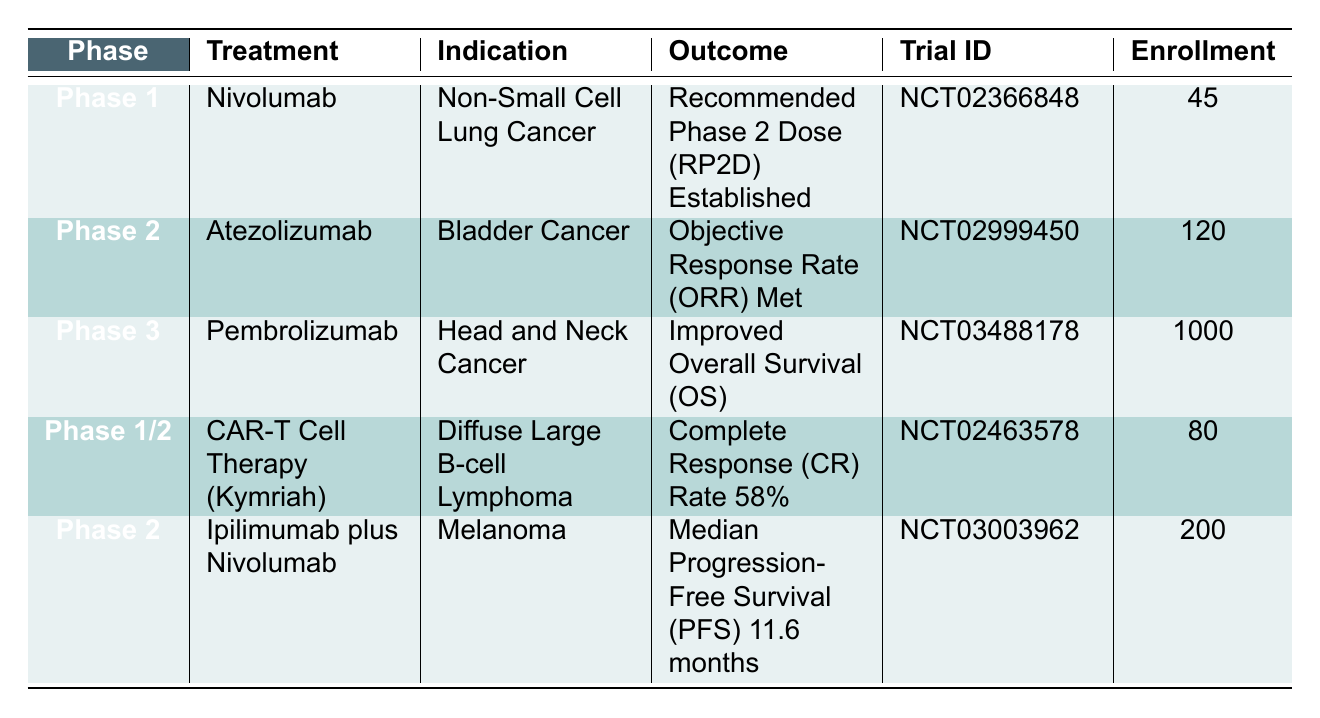What is the treatment used in the trial with ID NCT03003962? Referring to the table, the trial with ID NCT03003962 corresponds to the treatment "Ipilimumab plus Nivolumab."
Answer: Ipilimumab plus Nivolumab Which phase has the highest enrollment? By examining the enrollment column, Phase 3 with treatment Pembrolizumab has the highest number of enrollments at 1000.
Answer: Phase 3 Is the outcome of the CAR-T Cell Therapy trial a complete response rate? The table states that the outcome for the CAR-T Cell Therapy (Kymriah) trial is "Complete Response (CR) Rate 58%," confirming that the outcome is indeed a complete response rate.
Answer: Yes How many trials were conducted in Phase 2? The table indicates that there are two trials in Phase 2: one with Atezolizumab and another with Ipilimumab plus Nivolumab. Hence, the total count is two.
Answer: 2 What is the difference in enrollment between Phase 1 and Phase 1/2 trials? The total enrollment for Phase 1 trials (Nivolumab and CAR-T Cell Therapy) is 45 + 80 = 125. The enrollment for the Phase 1/2 trial is 80. Therefore, the difference is 125 - 80 = 45.
Answer: 45 Which treatment has an outcome describing improved overall survival? According to the table, the treatment "Pembrolizumab" in Phase 3 has the outcome of "Improved Overall Survival (OS)."
Answer: Pembrolizumab Is there a trial with an outcome of median progression-free survival? The trial for "Ipilimumab plus Nivolumab" lists "Median Progression-Free Survival (PFS) 11.6 months" as its outcome, confirming that there is such a trial.
Answer: Yes What is the total number of enrollees across all trials in the table? Adding the enrollment numbers from all trials gives a total of 45 + 120 + 1000 + 80 + 200 = 1445 enrollees across all trials listed in the table.
Answer: 1445 What is the earliest start date among the trials? The start dates provided for the trials are: 2015-02-01, 2016-03-01, 2017-09-01, 2016-05-20, and 2017-01-15. The earliest start date is 2015-02-01, which belongs to the trial for Nivolumab.
Answer: 2015-02-01 